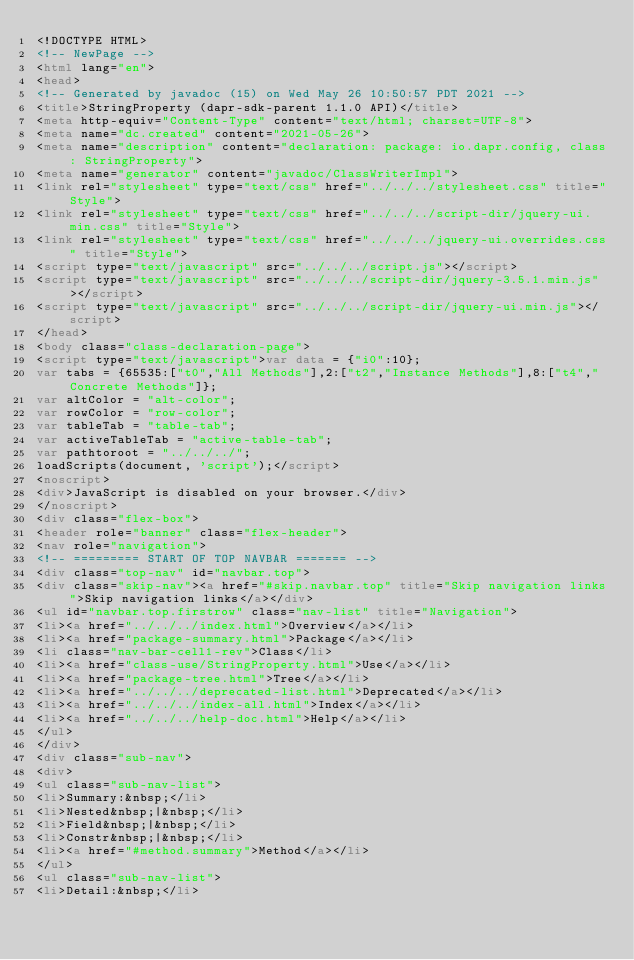Convert code to text. <code><loc_0><loc_0><loc_500><loc_500><_HTML_><!DOCTYPE HTML>
<!-- NewPage -->
<html lang="en">
<head>
<!-- Generated by javadoc (15) on Wed May 26 10:50:57 PDT 2021 -->
<title>StringProperty (dapr-sdk-parent 1.1.0 API)</title>
<meta http-equiv="Content-Type" content="text/html; charset=UTF-8">
<meta name="dc.created" content="2021-05-26">
<meta name="description" content="declaration: package: io.dapr.config, class: StringProperty">
<meta name="generator" content="javadoc/ClassWriterImpl">
<link rel="stylesheet" type="text/css" href="../../../stylesheet.css" title="Style">
<link rel="stylesheet" type="text/css" href="../../../script-dir/jquery-ui.min.css" title="Style">
<link rel="stylesheet" type="text/css" href="../../../jquery-ui.overrides.css" title="Style">
<script type="text/javascript" src="../../../script.js"></script>
<script type="text/javascript" src="../../../script-dir/jquery-3.5.1.min.js"></script>
<script type="text/javascript" src="../../../script-dir/jquery-ui.min.js"></script>
</head>
<body class="class-declaration-page">
<script type="text/javascript">var data = {"i0":10};
var tabs = {65535:["t0","All Methods"],2:["t2","Instance Methods"],8:["t4","Concrete Methods"]};
var altColor = "alt-color";
var rowColor = "row-color";
var tableTab = "table-tab";
var activeTableTab = "active-table-tab";
var pathtoroot = "../../../";
loadScripts(document, 'script');</script>
<noscript>
<div>JavaScript is disabled on your browser.</div>
</noscript>
<div class="flex-box">
<header role="banner" class="flex-header">
<nav role="navigation">
<!-- ========= START OF TOP NAVBAR ======= -->
<div class="top-nav" id="navbar.top">
<div class="skip-nav"><a href="#skip.navbar.top" title="Skip navigation links">Skip navigation links</a></div>
<ul id="navbar.top.firstrow" class="nav-list" title="Navigation">
<li><a href="../../../index.html">Overview</a></li>
<li><a href="package-summary.html">Package</a></li>
<li class="nav-bar-cell1-rev">Class</li>
<li><a href="class-use/StringProperty.html">Use</a></li>
<li><a href="package-tree.html">Tree</a></li>
<li><a href="../../../deprecated-list.html">Deprecated</a></li>
<li><a href="../../../index-all.html">Index</a></li>
<li><a href="../../../help-doc.html">Help</a></li>
</ul>
</div>
<div class="sub-nav">
<div>
<ul class="sub-nav-list">
<li>Summary:&nbsp;</li>
<li>Nested&nbsp;|&nbsp;</li>
<li>Field&nbsp;|&nbsp;</li>
<li>Constr&nbsp;|&nbsp;</li>
<li><a href="#method.summary">Method</a></li>
</ul>
<ul class="sub-nav-list">
<li>Detail:&nbsp;</li></code> 